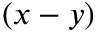<formula> <loc_0><loc_0><loc_500><loc_500>( x - y )</formula> 